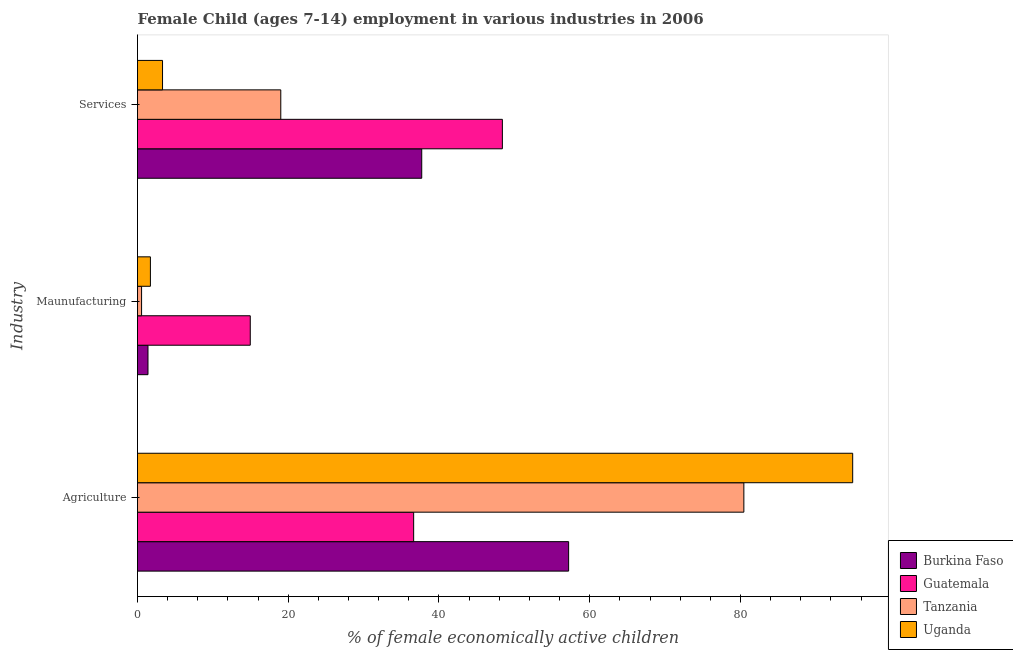Are the number of bars per tick equal to the number of legend labels?
Give a very brief answer. Yes. Are the number of bars on each tick of the Y-axis equal?
Your answer should be very brief. Yes. How many bars are there on the 3rd tick from the top?
Provide a succinct answer. 4. How many bars are there on the 2nd tick from the bottom?
Your answer should be very brief. 4. What is the label of the 3rd group of bars from the top?
Your answer should be very brief. Agriculture. What is the percentage of economically active children in manufacturing in Burkina Faso?
Provide a short and direct response. 1.39. Across all countries, what is the maximum percentage of economically active children in services?
Your answer should be compact. 48.41. Across all countries, what is the minimum percentage of economically active children in manufacturing?
Your response must be concise. 0.54. In which country was the percentage of economically active children in manufacturing maximum?
Your answer should be very brief. Guatemala. In which country was the percentage of economically active children in manufacturing minimum?
Your response must be concise. Tanzania. What is the total percentage of economically active children in agriculture in the graph?
Your answer should be very brief. 269.18. What is the difference between the percentage of economically active children in agriculture in Uganda and that in Tanzania?
Your answer should be very brief. 14.44. What is the difference between the percentage of economically active children in manufacturing in Burkina Faso and the percentage of economically active children in services in Guatemala?
Your response must be concise. -47.02. What is the average percentage of economically active children in manufacturing per country?
Keep it short and to the point. 4.65. What is the difference between the percentage of economically active children in services and percentage of economically active children in manufacturing in Tanzania?
Keep it short and to the point. 18.47. In how many countries, is the percentage of economically active children in services greater than 52 %?
Your answer should be compact. 0. What is the ratio of the percentage of economically active children in manufacturing in Guatemala to that in Tanzania?
Keep it short and to the point. 27.7. Is the percentage of economically active children in agriculture in Burkina Faso less than that in Guatemala?
Ensure brevity in your answer.  No. Is the difference between the percentage of economically active children in manufacturing in Burkina Faso and Uganda greater than the difference between the percentage of economically active children in services in Burkina Faso and Uganda?
Offer a terse response. No. What is the difference between the highest and the second highest percentage of economically active children in agriculture?
Your answer should be very brief. 14.44. What is the difference between the highest and the lowest percentage of economically active children in services?
Your response must be concise. 45.09. Is the sum of the percentage of economically active children in manufacturing in Burkina Faso and Guatemala greater than the maximum percentage of economically active children in agriculture across all countries?
Offer a very short reply. No. What does the 1st bar from the top in Agriculture represents?
Provide a short and direct response. Uganda. What does the 2nd bar from the bottom in Services represents?
Ensure brevity in your answer.  Guatemala. How many bars are there?
Your response must be concise. 12. How many countries are there in the graph?
Keep it short and to the point. 4. Does the graph contain any zero values?
Your response must be concise. No. Does the graph contain grids?
Provide a short and direct response. No. Where does the legend appear in the graph?
Offer a very short reply. Bottom right. What is the title of the graph?
Make the answer very short. Female Child (ages 7-14) employment in various industries in 2006. What is the label or title of the X-axis?
Your answer should be compact. % of female economically active children. What is the label or title of the Y-axis?
Your answer should be compact. Industry. What is the % of female economically active children of Burkina Faso in Agriculture?
Ensure brevity in your answer.  57.2. What is the % of female economically active children of Guatemala in Agriculture?
Keep it short and to the point. 36.64. What is the % of female economically active children of Tanzania in Agriculture?
Your response must be concise. 80.45. What is the % of female economically active children in Uganda in Agriculture?
Your answer should be compact. 94.89. What is the % of female economically active children in Burkina Faso in Maunufacturing?
Keep it short and to the point. 1.39. What is the % of female economically active children in Guatemala in Maunufacturing?
Provide a succinct answer. 14.96. What is the % of female economically active children in Tanzania in Maunufacturing?
Offer a very short reply. 0.54. What is the % of female economically active children of Uganda in Maunufacturing?
Keep it short and to the point. 1.71. What is the % of female economically active children in Burkina Faso in Services?
Your answer should be very brief. 37.71. What is the % of female economically active children in Guatemala in Services?
Your answer should be very brief. 48.41. What is the % of female economically active children of Tanzania in Services?
Offer a very short reply. 19.01. What is the % of female economically active children in Uganda in Services?
Offer a terse response. 3.32. Across all Industry, what is the maximum % of female economically active children of Burkina Faso?
Keep it short and to the point. 57.2. Across all Industry, what is the maximum % of female economically active children of Guatemala?
Make the answer very short. 48.41. Across all Industry, what is the maximum % of female economically active children in Tanzania?
Your answer should be compact. 80.45. Across all Industry, what is the maximum % of female economically active children of Uganda?
Your answer should be very brief. 94.89. Across all Industry, what is the minimum % of female economically active children of Burkina Faso?
Give a very brief answer. 1.39. Across all Industry, what is the minimum % of female economically active children in Guatemala?
Keep it short and to the point. 14.96. Across all Industry, what is the minimum % of female economically active children of Tanzania?
Your answer should be very brief. 0.54. Across all Industry, what is the minimum % of female economically active children in Uganda?
Provide a short and direct response. 1.71. What is the total % of female economically active children of Burkina Faso in the graph?
Your response must be concise. 96.3. What is the total % of female economically active children of Guatemala in the graph?
Your response must be concise. 100.01. What is the total % of female economically active children in Tanzania in the graph?
Make the answer very short. 100. What is the total % of female economically active children of Uganda in the graph?
Make the answer very short. 99.92. What is the difference between the % of female economically active children of Burkina Faso in Agriculture and that in Maunufacturing?
Provide a succinct answer. 55.81. What is the difference between the % of female economically active children in Guatemala in Agriculture and that in Maunufacturing?
Your answer should be very brief. 21.68. What is the difference between the % of female economically active children of Tanzania in Agriculture and that in Maunufacturing?
Your answer should be very brief. 79.91. What is the difference between the % of female economically active children in Uganda in Agriculture and that in Maunufacturing?
Offer a very short reply. 93.18. What is the difference between the % of female economically active children of Burkina Faso in Agriculture and that in Services?
Ensure brevity in your answer.  19.49. What is the difference between the % of female economically active children of Guatemala in Agriculture and that in Services?
Make the answer very short. -11.77. What is the difference between the % of female economically active children in Tanzania in Agriculture and that in Services?
Give a very brief answer. 61.44. What is the difference between the % of female economically active children in Uganda in Agriculture and that in Services?
Your answer should be compact. 91.57. What is the difference between the % of female economically active children of Burkina Faso in Maunufacturing and that in Services?
Provide a succinct answer. -36.32. What is the difference between the % of female economically active children of Guatemala in Maunufacturing and that in Services?
Your answer should be compact. -33.45. What is the difference between the % of female economically active children of Tanzania in Maunufacturing and that in Services?
Give a very brief answer. -18.47. What is the difference between the % of female economically active children of Uganda in Maunufacturing and that in Services?
Ensure brevity in your answer.  -1.61. What is the difference between the % of female economically active children of Burkina Faso in Agriculture and the % of female economically active children of Guatemala in Maunufacturing?
Provide a short and direct response. 42.24. What is the difference between the % of female economically active children in Burkina Faso in Agriculture and the % of female economically active children in Tanzania in Maunufacturing?
Make the answer very short. 56.66. What is the difference between the % of female economically active children of Burkina Faso in Agriculture and the % of female economically active children of Uganda in Maunufacturing?
Your answer should be compact. 55.49. What is the difference between the % of female economically active children of Guatemala in Agriculture and the % of female economically active children of Tanzania in Maunufacturing?
Ensure brevity in your answer.  36.1. What is the difference between the % of female economically active children of Guatemala in Agriculture and the % of female economically active children of Uganda in Maunufacturing?
Your answer should be compact. 34.93. What is the difference between the % of female economically active children in Tanzania in Agriculture and the % of female economically active children in Uganda in Maunufacturing?
Provide a short and direct response. 78.74. What is the difference between the % of female economically active children of Burkina Faso in Agriculture and the % of female economically active children of Guatemala in Services?
Offer a very short reply. 8.79. What is the difference between the % of female economically active children in Burkina Faso in Agriculture and the % of female economically active children in Tanzania in Services?
Provide a succinct answer. 38.19. What is the difference between the % of female economically active children in Burkina Faso in Agriculture and the % of female economically active children in Uganda in Services?
Give a very brief answer. 53.88. What is the difference between the % of female economically active children in Guatemala in Agriculture and the % of female economically active children in Tanzania in Services?
Make the answer very short. 17.63. What is the difference between the % of female economically active children in Guatemala in Agriculture and the % of female economically active children in Uganda in Services?
Your answer should be compact. 33.32. What is the difference between the % of female economically active children of Tanzania in Agriculture and the % of female economically active children of Uganda in Services?
Provide a succinct answer. 77.13. What is the difference between the % of female economically active children in Burkina Faso in Maunufacturing and the % of female economically active children in Guatemala in Services?
Keep it short and to the point. -47.02. What is the difference between the % of female economically active children in Burkina Faso in Maunufacturing and the % of female economically active children in Tanzania in Services?
Make the answer very short. -17.62. What is the difference between the % of female economically active children of Burkina Faso in Maunufacturing and the % of female economically active children of Uganda in Services?
Provide a short and direct response. -1.93. What is the difference between the % of female economically active children in Guatemala in Maunufacturing and the % of female economically active children in Tanzania in Services?
Give a very brief answer. -4.05. What is the difference between the % of female economically active children in Guatemala in Maunufacturing and the % of female economically active children in Uganda in Services?
Give a very brief answer. 11.64. What is the difference between the % of female economically active children of Tanzania in Maunufacturing and the % of female economically active children of Uganda in Services?
Your response must be concise. -2.78. What is the average % of female economically active children in Burkina Faso per Industry?
Provide a succinct answer. 32.1. What is the average % of female economically active children in Guatemala per Industry?
Offer a very short reply. 33.34. What is the average % of female economically active children of Tanzania per Industry?
Ensure brevity in your answer.  33.33. What is the average % of female economically active children in Uganda per Industry?
Provide a succinct answer. 33.31. What is the difference between the % of female economically active children in Burkina Faso and % of female economically active children in Guatemala in Agriculture?
Provide a succinct answer. 20.56. What is the difference between the % of female economically active children in Burkina Faso and % of female economically active children in Tanzania in Agriculture?
Keep it short and to the point. -23.25. What is the difference between the % of female economically active children in Burkina Faso and % of female economically active children in Uganda in Agriculture?
Keep it short and to the point. -37.69. What is the difference between the % of female economically active children in Guatemala and % of female economically active children in Tanzania in Agriculture?
Provide a succinct answer. -43.81. What is the difference between the % of female economically active children of Guatemala and % of female economically active children of Uganda in Agriculture?
Your answer should be compact. -58.25. What is the difference between the % of female economically active children of Tanzania and % of female economically active children of Uganda in Agriculture?
Give a very brief answer. -14.44. What is the difference between the % of female economically active children in Burkina Faso and % of female economically active children in Guatemala in Maunufacturing?
Give a very brief answer. -13.57. What is the difference between the % of female economically active children of Burkina Faso and % of female economically active children of Tanzania in Maunufacturing?
Ensure brevity in your answer.  0.85. What is the difference between the % of female economically active children of Burkina Faso and % of female economically active children of Uganda in Maunufacturing?
Provide a short and direct response. -0.32. What is the difference between the % of female economically active children in Guatemala and % of female economically active children in Tanzania in Maunufacturing?
Make the answer very short. 14.42. What is the difference between the % of female economically active children of Guatemala and % of female economically active children of Uganda in Maunufacturing?
Your answer should be very brief. 13.25. What is the difference between the % of female economically active children in Tanzania and % of female economically active children in Uganda in Maunufacturing?
Make the answer very short. -1.17. What is the difference between the % of female economically active children in Burkina Faso and % of female economically active children in Guatemala in Services?
Give a very brief answer. -10.7. What is the difference between the % of female economically active children in Burkina Faso and % of female economically active children in Tanzania in Services?
Make the answer very short. 18.7. What is the difference between the % of female economically active children of Burkina Faso and % of female economically active children of Uganda in Services?
Your answer should be very brief. 34.39. What is the difference between the % of female economically active children in Guatemala and % of female economically active children in Tanzania in Services?
Your answer should be very brief. 29.4. What is the difference between the % of female economically active children in Guatemala and % of female economically active children in Uganda in Services?
Provide a short and direct response. 45.09. What is the difference between the % of female economically active children of Tanzania and % of female economically active children of Uganda in Services?
Keep it short and to the point. 15.69. What is the ratio of the % of female economically active children of Burkina Faso in Agriculture to that in Maunufacturing?
Make the answer very short. 41.15. What is the ratio of the % of female economically active children of Guatemala in Agriculture to that in Maunufacturing?
Give a very brief answer. 2.45. What is the ratio of the % of female economically active children in Tanzania in Agriculture to that in Maunufacturing?
Your answer should be compact. 148.98. What is the ratio of the % of female economically active children in Uganda in Agriculture to that in Maunufacturing?
Keep it short and to the point. 55.49. What is the ratio of the % of female economically active children of Burkina Faso in Agriculture to that in Services?
Provide a short and direct response. 1.52. What is the ratio of the % of female economically active children of Guatemala in Agriculture to that in Services?
Your answer should be very brief. 0.76. What is the ratio of the % of female economically active children of Tanzania in Agriculture to that in Services?
Keep it short and to the point. 4.23. What is the ratio of the % of female economically active children in Uganda in Agriculture to that in Services?
Offer a terse response. 28.58. What is the ratio of the % of female economically active children of Burkina Faso in Maunufacturing to that in Services?
Provide a succinct answer. 0.04. What is the ratio of the % of female economically active children of Guatemala in Maunufacturing to that in Services?
Keep it short and to the point. 0.31. What is the ratio of the % of female economically active children of Tanzania in Maunufacturing to that in Services?
Ensure brevity in your answer.  0.03. What is the ratio of the % of female economically active children in Uganda in Maunufacturing to that in Services?
Provide a short and direct response. 0.52. What is the difference between the highest and the second highest % of female economically active children in Burkina Faso?
Your answer should be very brief. 19.49. What is the difference between the highest and the second highest % of female economically active children in Guatemala?
Provide a short and direct response. 11.77. What is the difference between the highest and the second highest % of female economically active children of Tanzania?
Your answer should be very brief. 61.44. What is the difference between the highest and the second highest % of female economically active children of Uganda?
Your response must be concise. 91.57. What is the difference between the highest and the lowest % of female economically active children in Burkina Faso?
Provide a succinct answer. 55.81. What is the difference between the highest and the lowest % of female economically active children in Guatemala?
Keep it short and to the point. 33.45. What is the difference between the highest and the lowest % of female economically active children in Tanzania?
Offer a terse response. 79.91. What is the difference between the highest and the lowest % of female economically active children of Uganda?
Offer a terse response. 93.18. 